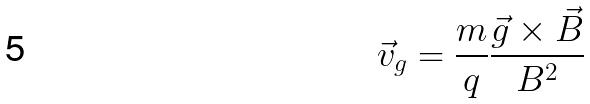<formula> <loc_0><loc_0><loc_500><loc_500>\vec { v } _ { g } = \frac { m } { q } \frac { \vec { g } \times \vec { B } } { B ^ { 2 } }</formula> 